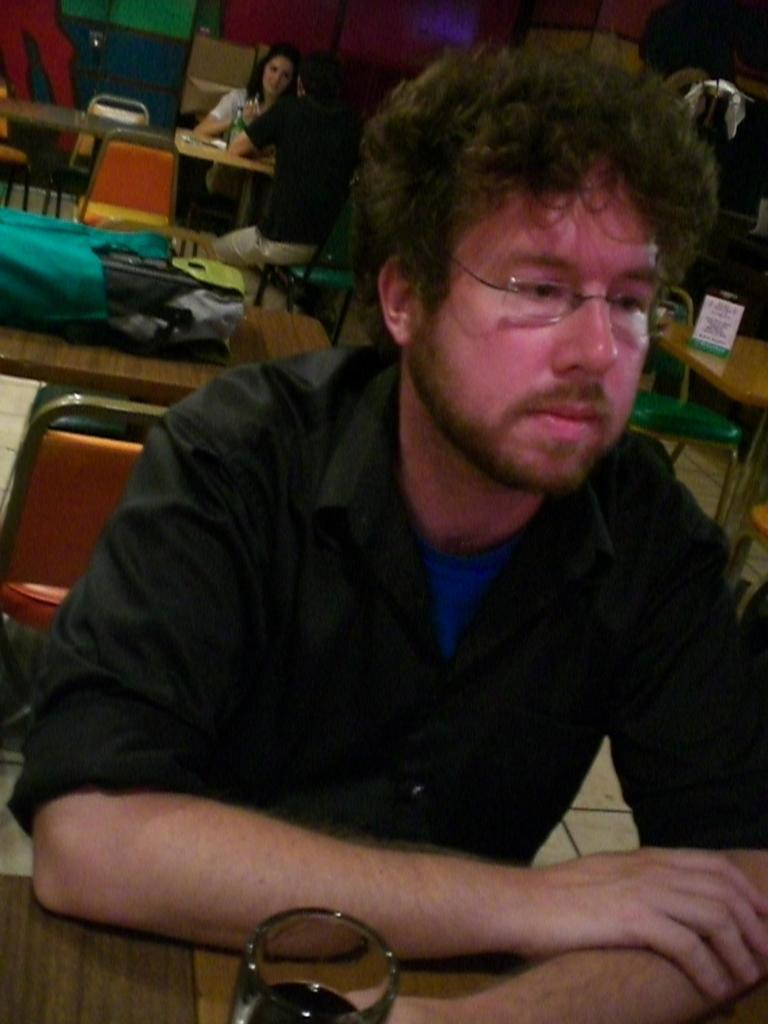What is the man in the image doing? The man is sitting on a chair in the image. What is on the table in front of the man? There is a glass on a table in front of the man. What can be seen in the background of the image? There are objects on tables, chairs, and people in the background. What year is the machine being used in the image? There is no machine present in the image, so it is not possible to determine the year it is being used. 